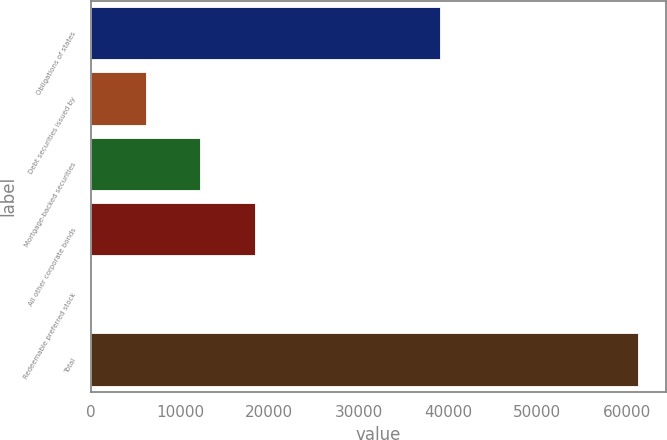<chart> <loc_0><loc_0><loc_500><loc_500><bar_chart><fcel>Obligations of states<fcel>Debt securities issued by<fcel>Mortgage-backed securities<fcel>All other corporate bonds<fcel>Redeemable preferred stock<fcel>Total<nl><fcel>39062<fcel>6178.8<fcel>12300.6<fcel>18422.4<fcel>57<fcel>61275<nl></chart> 